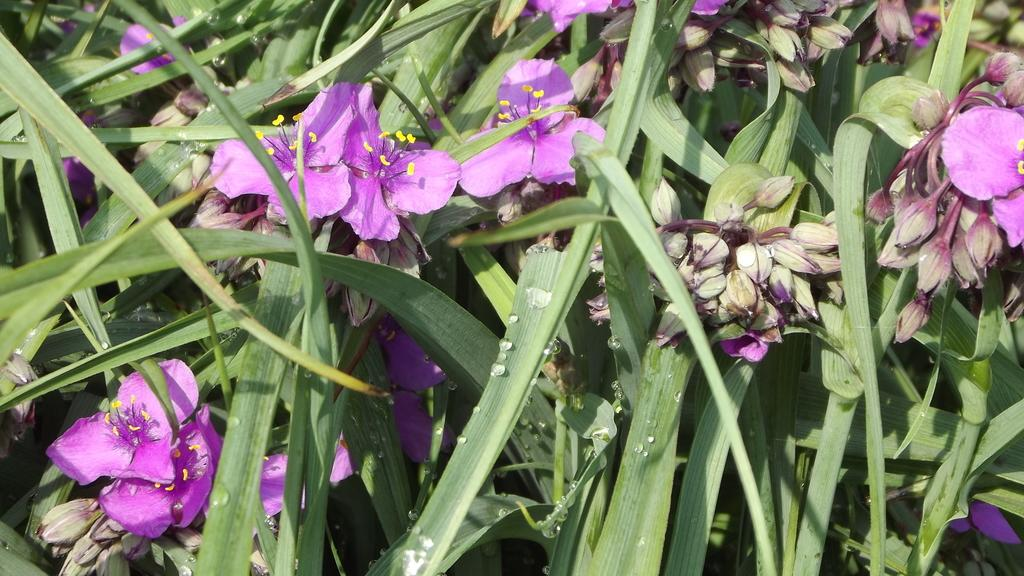What type of plant life is present in the image? There are flowers, buds, and leaves in the image. Can you describe the different stages of growth depicted in the image? The image shows flowers in full bloom and buds that have not yet opened. What part of the plant is visible in the image? The flowers, buds, and leaves are visible in the image. What type of note can be seen attached to the flowers in the image? There is no note present in the image; it only features flowers, buds, and leaves. 